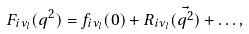Convert formula to latex. <formula><loc_0><loc_0><loc_500><loc_500>F _ { i \nu _ { l } } ( q ^ { 2 } ) = f _ { i \nu _ { l } } ( 0 ) + R _ { i \nu _ { l } } ( \vec { q ^ { 2 } } ) + \dots ,</formula> 